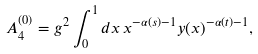Convert formula to latex. <formula><loc_0><loc_0><loc_500><loc_500>A _ { 4 } ^ { ( 0 ) } = g ^ { 2 } \int _ { 0 } ^ { 1 } d x \, x ^ { - \alpha ( s ) - 1 } y ( x ) ^ { - \alpha ( t ) - 1 } ,</formula> 